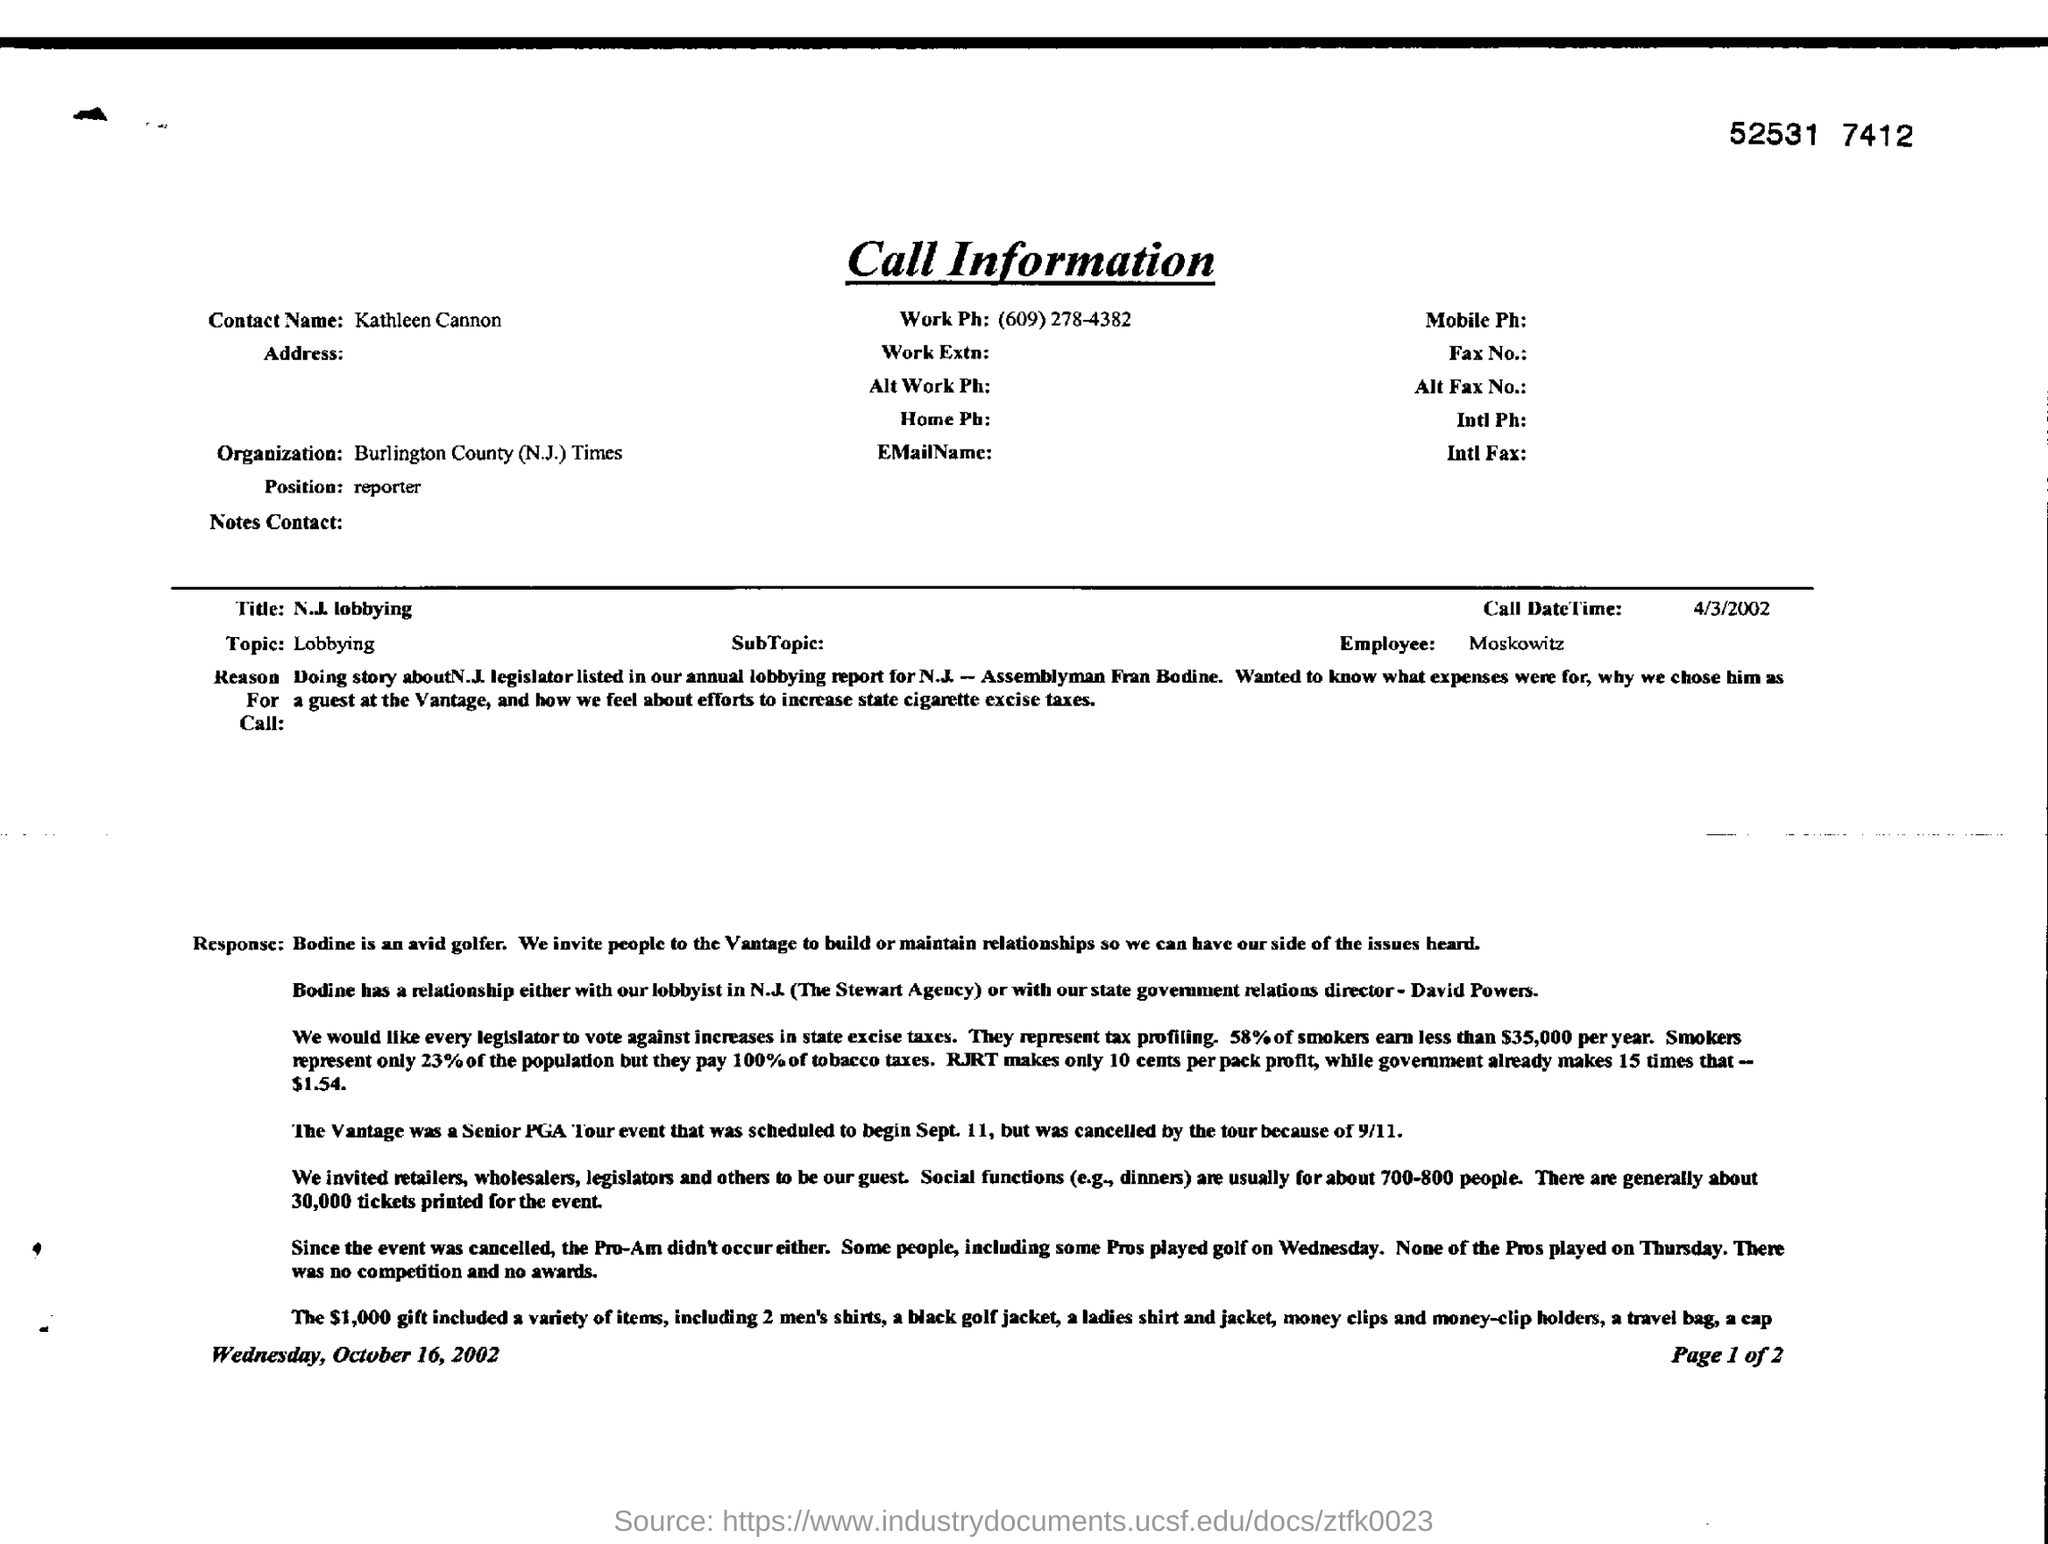Mention a couple of crucial points in this snapshot. Lobbying is written as "Topic" in a certain context. The position marked in the document is unknown to the reporter. The value of gifts, including shirts, is $1,000. The call date time is a specific date and time that can be used to identify and track a particular call. The format of the call date time is typically in the format of "Month Day, Year" and represents the date and time when the call was made. For example, the call date time "4/3/2002" represents April 3rd, 2002. 